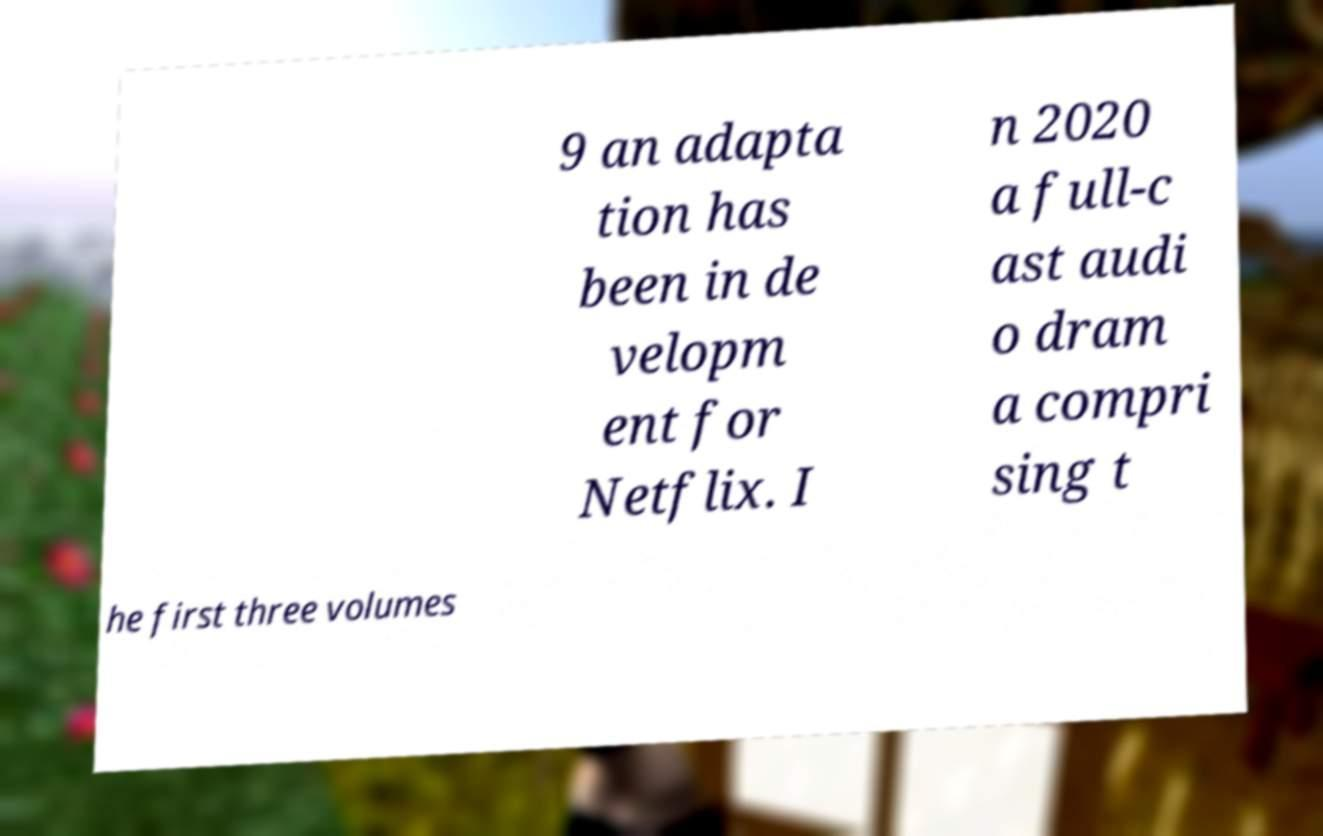Can you accurately transcribe the text from the provided image for me? 9 an adapta tion has been in de velopm ent for Netflix. I n 2020 a full-c ast audi o dram a compri sing t he first three volumes 